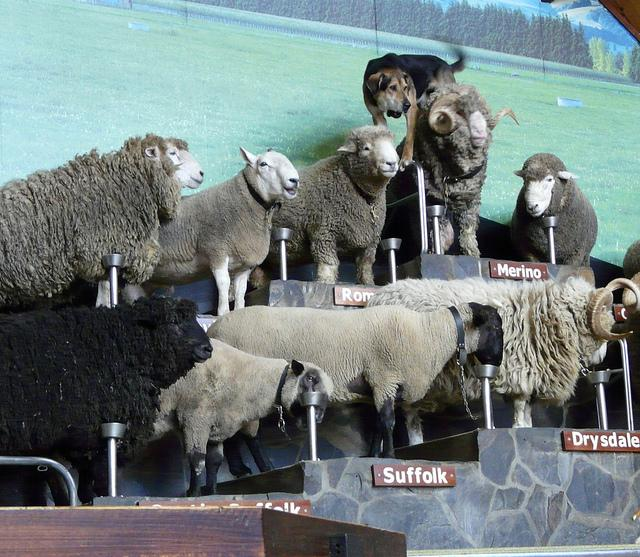What is at the top of the sheep pile?

Choices:
A) dog
B) elephant
C) baby
D) mouse dog 